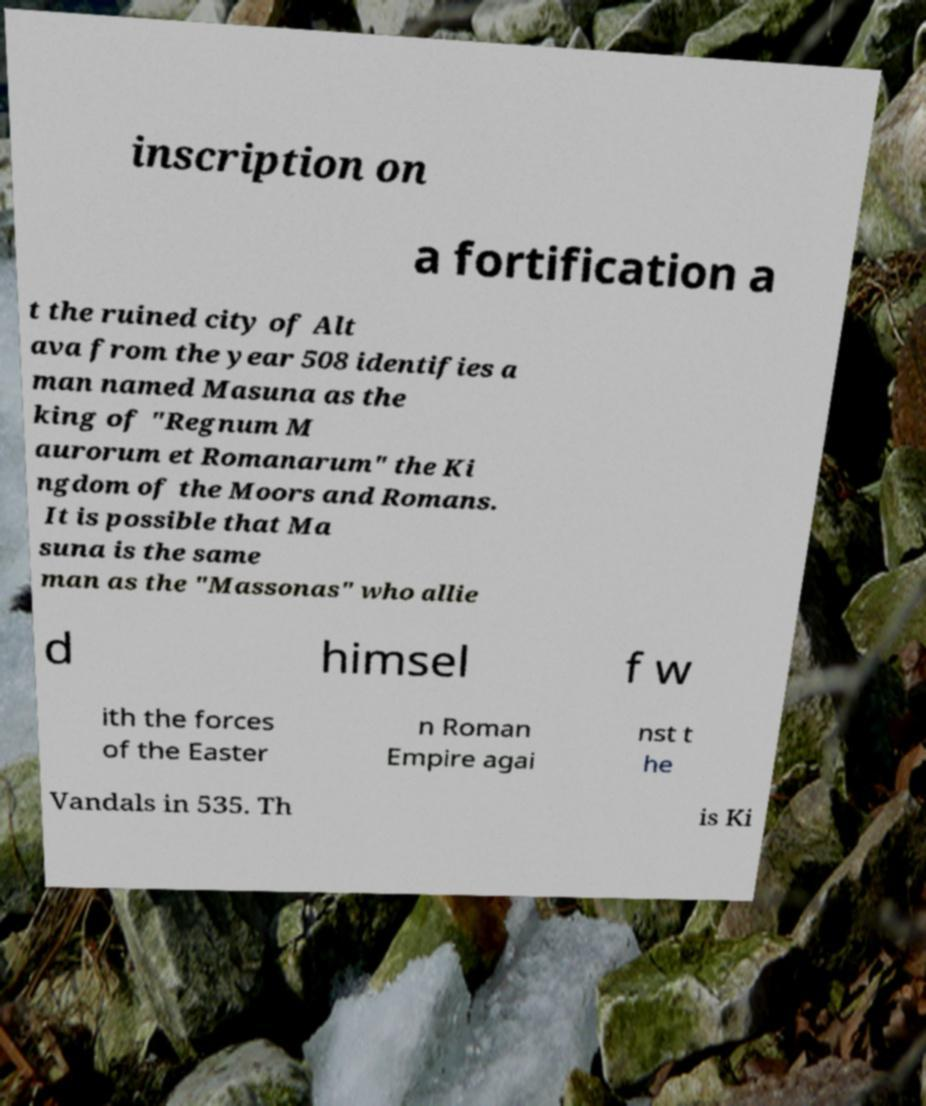Could you assist in decoding the text presented in this image and type it out clearly? inscription on a fortification a t the ruined city of Alt ava from the year 508 identifies a man named Masuna as the king of "Regnum M aurorum et Romanarum" the Ki ngdom of the Moors and Romans. It is possible that Ma suna is the same man as the "Massonas" who allie d himsel f w ith the forces of the Easter n Roman Empire agai nst t he Vandals in 535. Th is Ki 